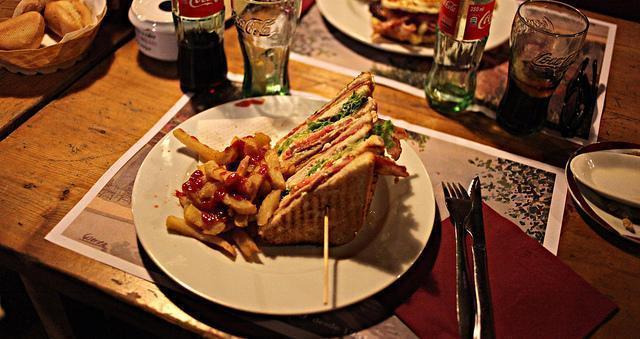What is the name of this sandwich?
Indicate the correct response by choosing from the four available options to answer the question.
Options: Monte cristo, club sandwich, reuben, hoagie. Club sandwich. 